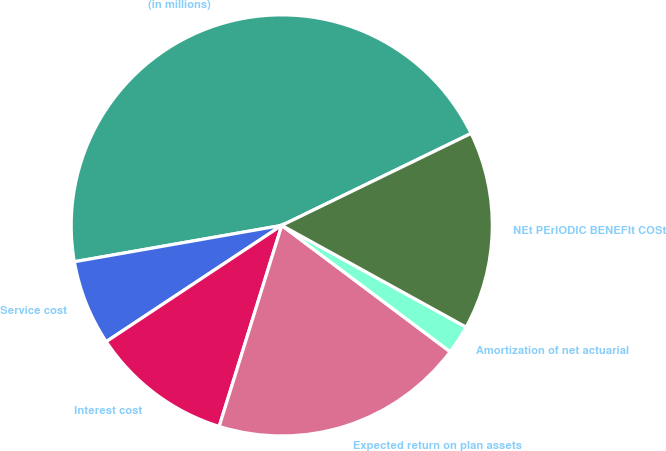Convert chart to OTSL. <chart><loc_0><loc_0><loc_500><loc_500><pie_chart><fcel>(in millions)<fcel>Service cost<fcel>Interest cost<fcel>Expected return on plan assets<fcel>Amortization of net actuarial<fcel>NEt PErIODIC BENEFIt COSt<nl><fcel>45.57%<fcel>6.55%<fcel>10.89%<fcel>19.56%<fcel>2.22%<fcel>15.22%<nl></chart> 